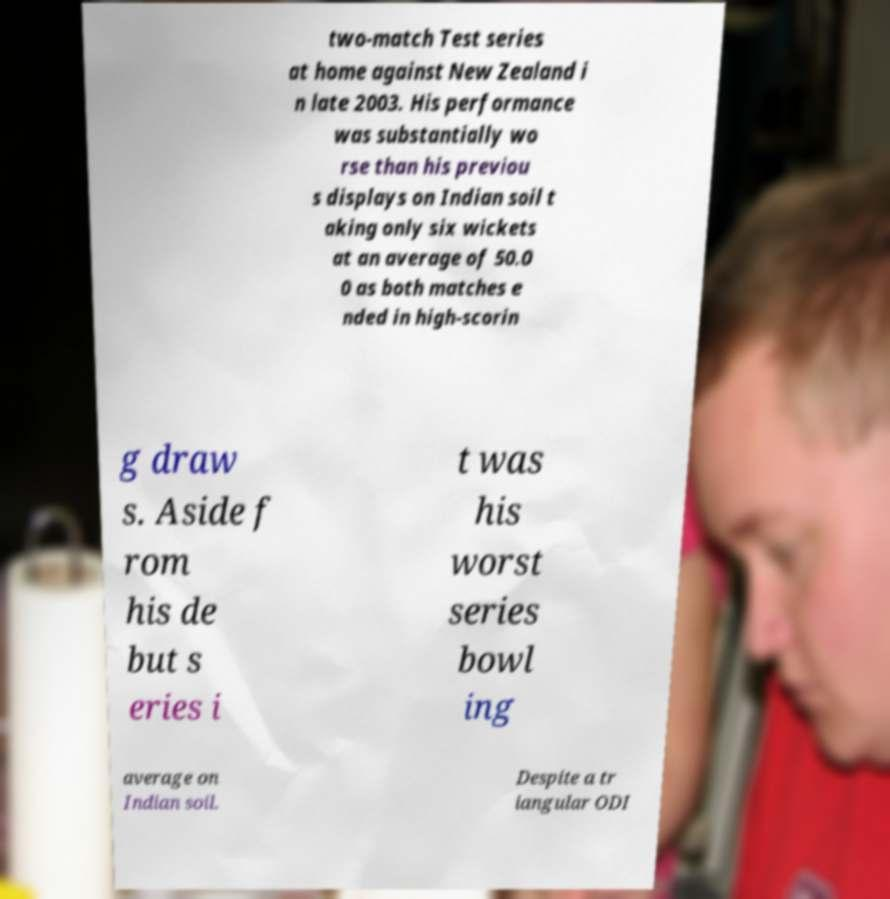There's text embedded in this image that I need extracted. Can you transcribe it verbatim? two-match Test series at home against New Zealand i n late 2003. His performance was substantially wo rse than his previou s displays on Indian soil t aking only six wickets at an average of 50.0 0 as both matches e nded in high-scorin g draw s. Aside f rom his de but s eries i t was his worst series bowl ing average on Indian soil. Despite a tr iangular ODI 